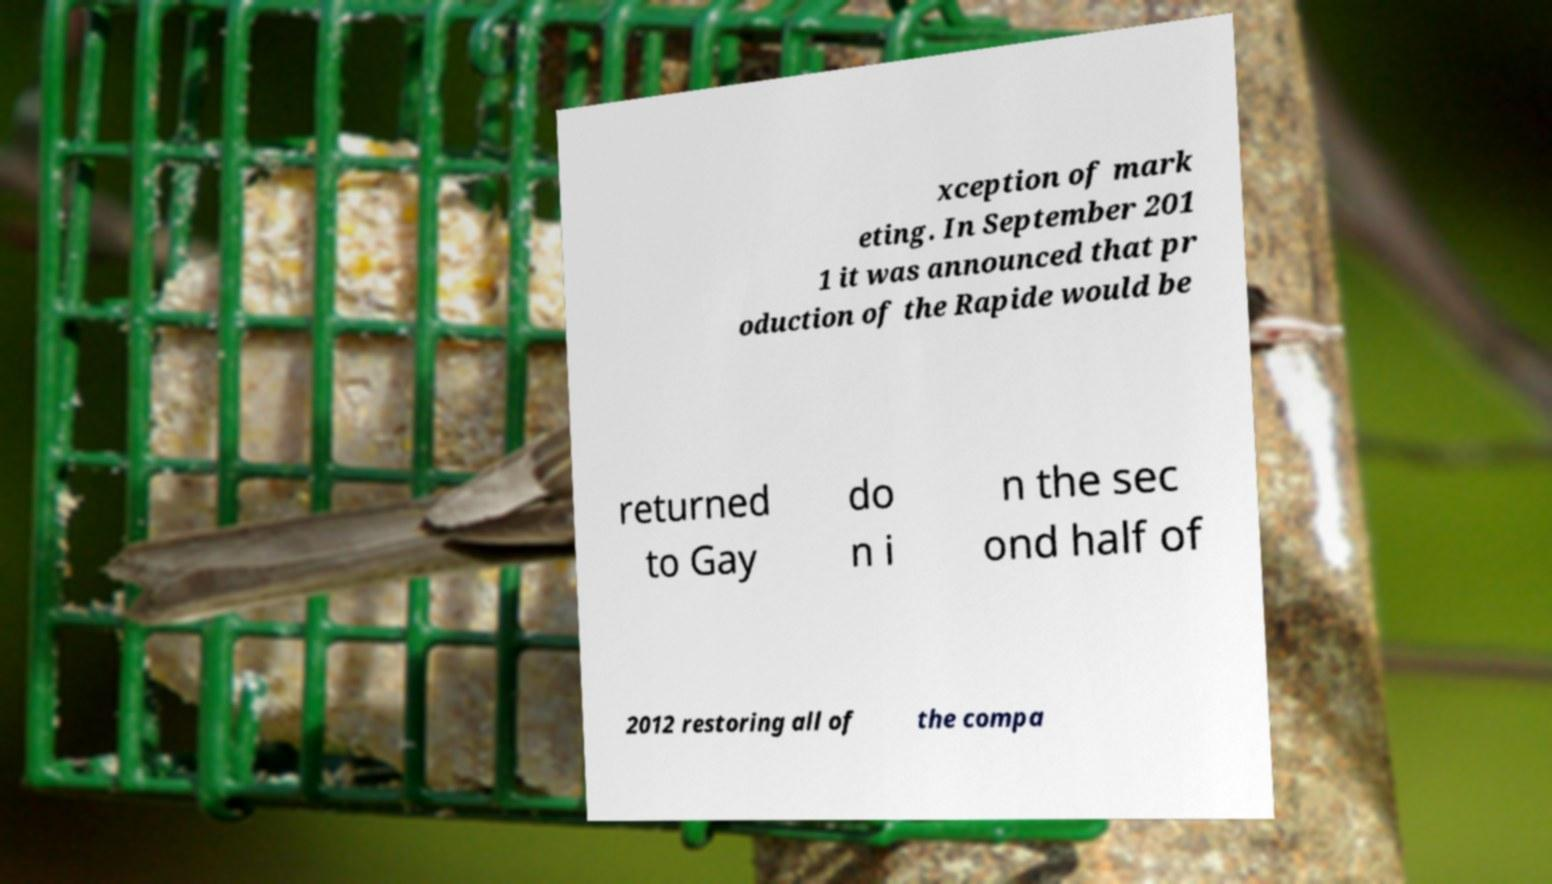For documentation purposes, I need the text within this image transcribed. Could you provide that? xception of mark eting. In September 201 1 it was announced that pr oduction of the Rapide would be returned to Gay do n i n the sec ond half of 2012 restoring all of the compa 